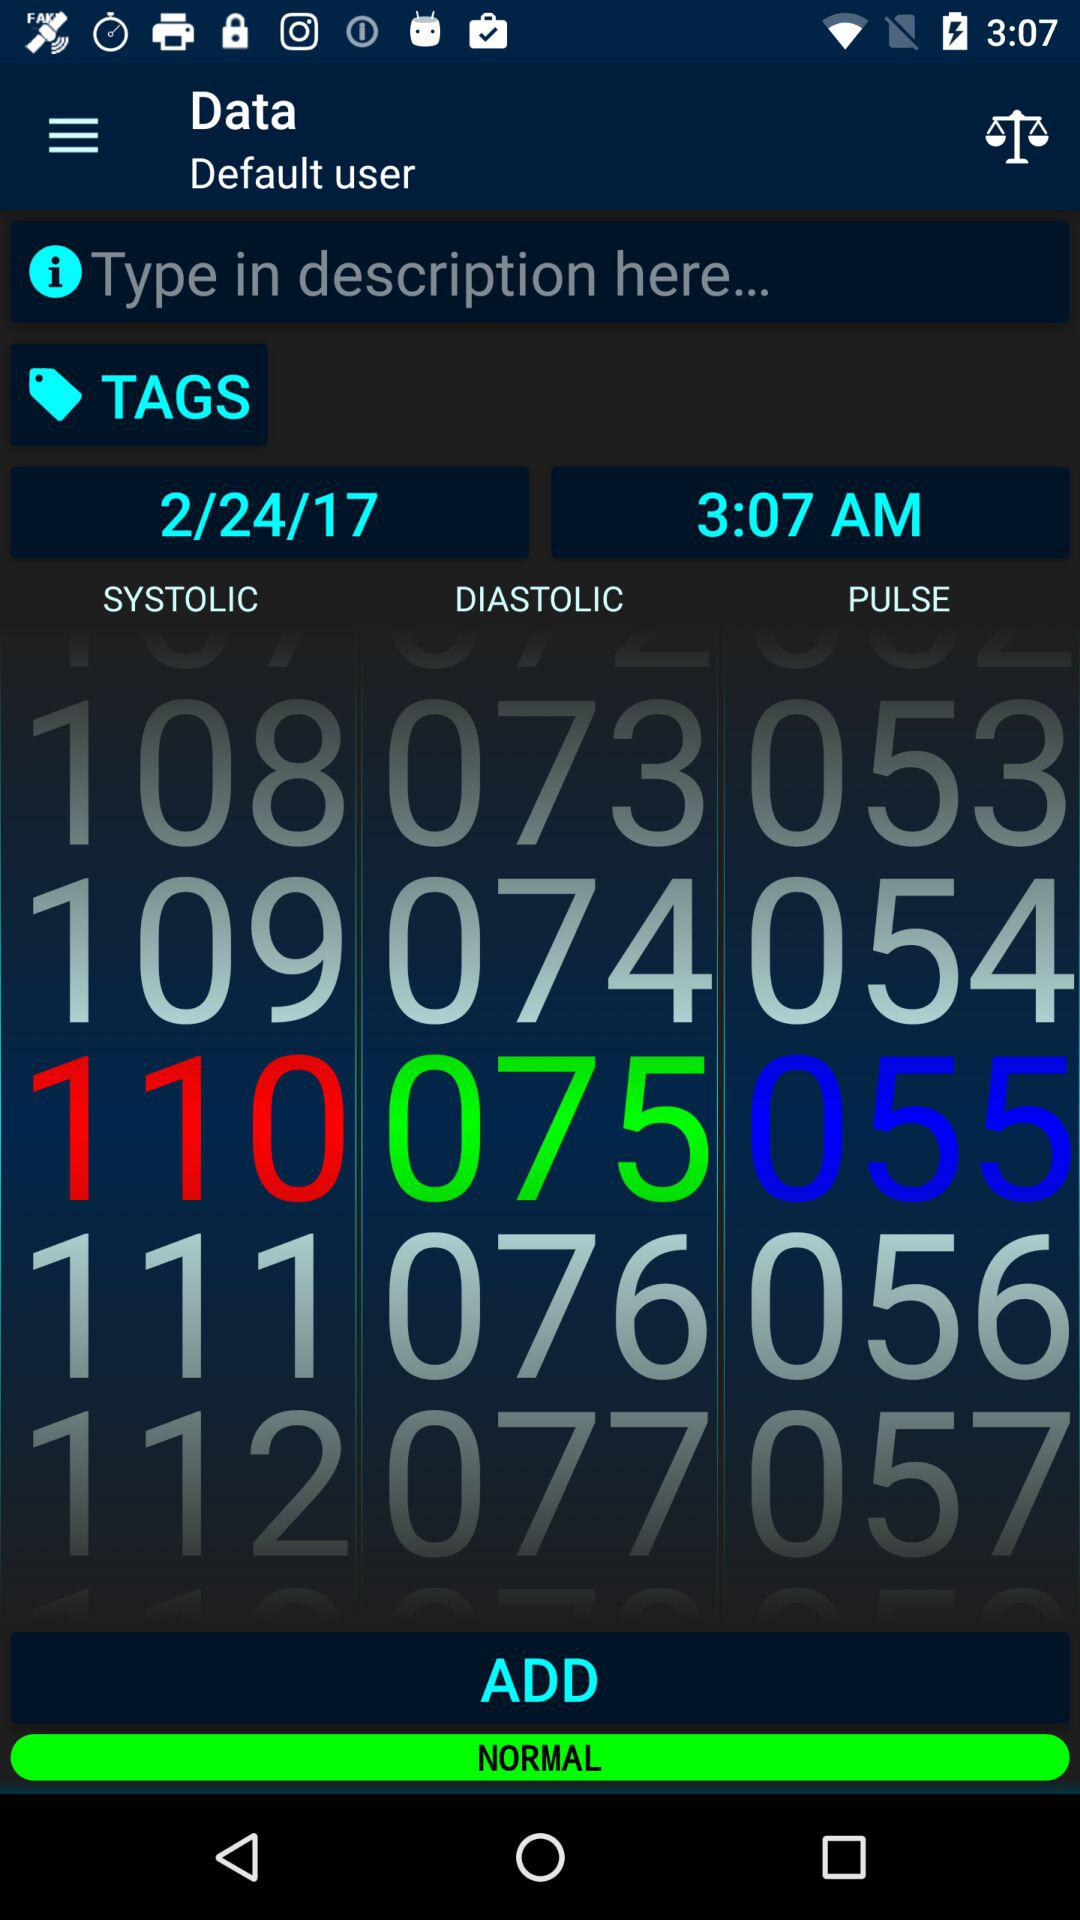What is the selected date? The selected date is 2/24/17. 